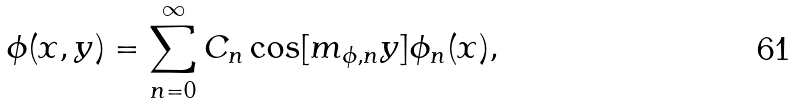Convert formula to latex. <formula><loc_0><loc_0><loc_500><loc_500>\phi ( x , y ) = \sum _ { n = 0 } ^ { \infty } C _ { n } \cos [ m _ { \phi , n } y ] \phi _ { n } ( x ) ,</formula> 